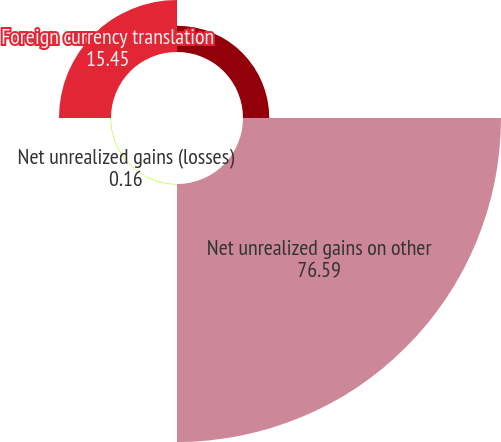<chart> <loc_0><loc_0><loc_500><loc_500><pie_chart><fcel>Noncredit other-than-temporary<fcel>Net unrealized gains on other<fcel>Net unrealized gains (losses)<fcel>Foreign currency translation<nl><fcel>7.8%<fcel>76.59%<fcel>0.16%<fcel>15.45%<nl></chart> 